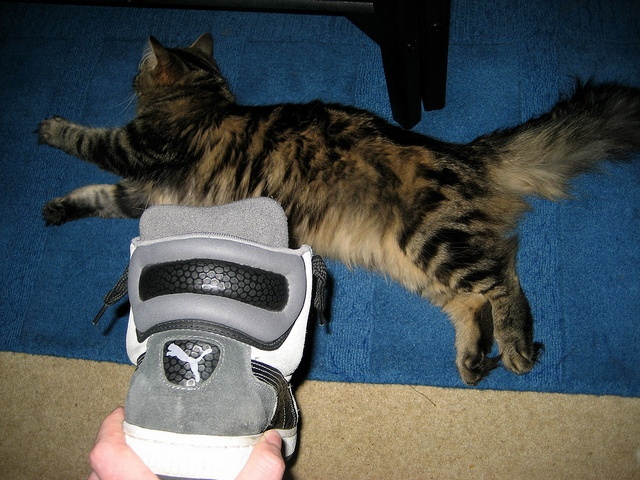Describe the objects in this image and their specific colors. I can see cat in black and gray tones and people in black, pink, lightpink, and gray tones in this image. 